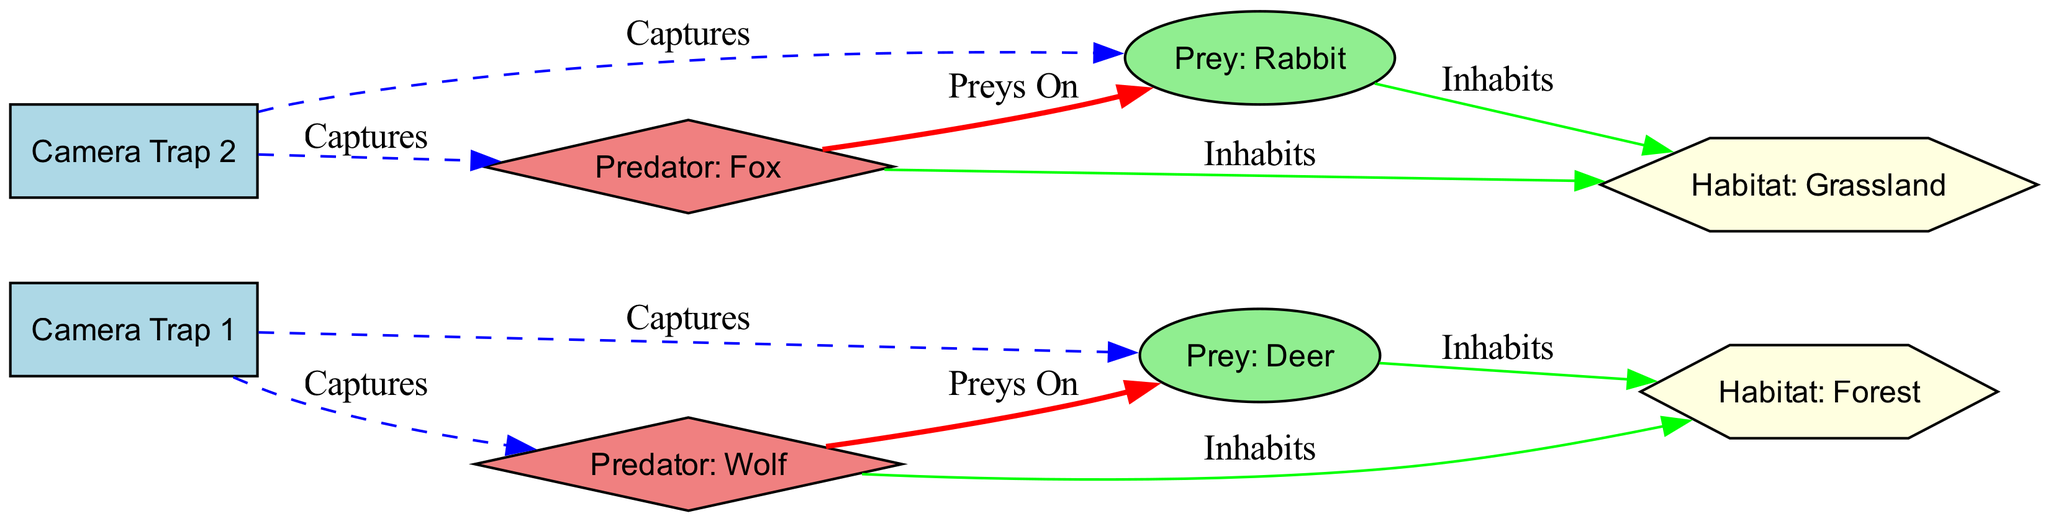What is the total number of nodes in the diagram? The total number of nodes can be counted directly from the provided data. There are 8 nodes listed: 2 camera traps, 2 prey species, 2 predator species, and 2 habitat types.
Answer: 8 Which camera trap captures Deer? By examining the edges, we see that the edge from "Camera Trap 1" to "Prey: Deer" has the label "Captures", indicating that this camera captures Deer.
Answer: Camera Trap 1 How many types of habitats are shown in the diagram? The diagram contains two habitats as indicated by the nodes: "Habitat: Grassland" and "Habitat: Forest". Therefore, we can conclude that there are 2 types of habitats.
Answer: 2 Which predator preys on Rabbit? The connection labeled "Preys On" from "Predator: Fox" to "Prey: Rabbit" indicates that the Fox preys on the Rabbit.
Answer: Predator: Fox Inhabiting which habitat is Deer associated with? The edge shows that "Prey: Deer" is connected to "Habitat: Forest" with the label "Inhabits", thus Deer is associated with the Forest habitat.
Answer: Habitat: Forest What color represents a predator in the diagram? The nodes representing predators, such as "Predator: Wolf" and "Predator: Fox", are filled with the color light coral, as defined in the node styles.
Answer: Light coral How many edges are labeled "Captures"? By analyzing the edges, we find 4 edges where the label is "Captures": Camera Trap 1 to Prey: Deer, Camera Trap 1 to Predator: Wolf, Camera Trap 2 to Prey: Rabbit, and Camera Trap 2 to Predator: Fox.
Answer: 4 What do Rabbits inhabit according to the diagram? The edge shows that "Prey: Rabbit" connects to "Habitat: Grassland" with the label "Inhabits", indicating that Rabbits inhabit the Grassland habitat.
Answer: Habitat: Grassland Which prey is associated with the Forest habitat? Analyzing the edges reveals that "Prey: Deer" is connected to "Habitat: Forest" through the label "Inhabits", indicating that Deer is associated with the Forest habitat.
Answer: Prey: Deer 